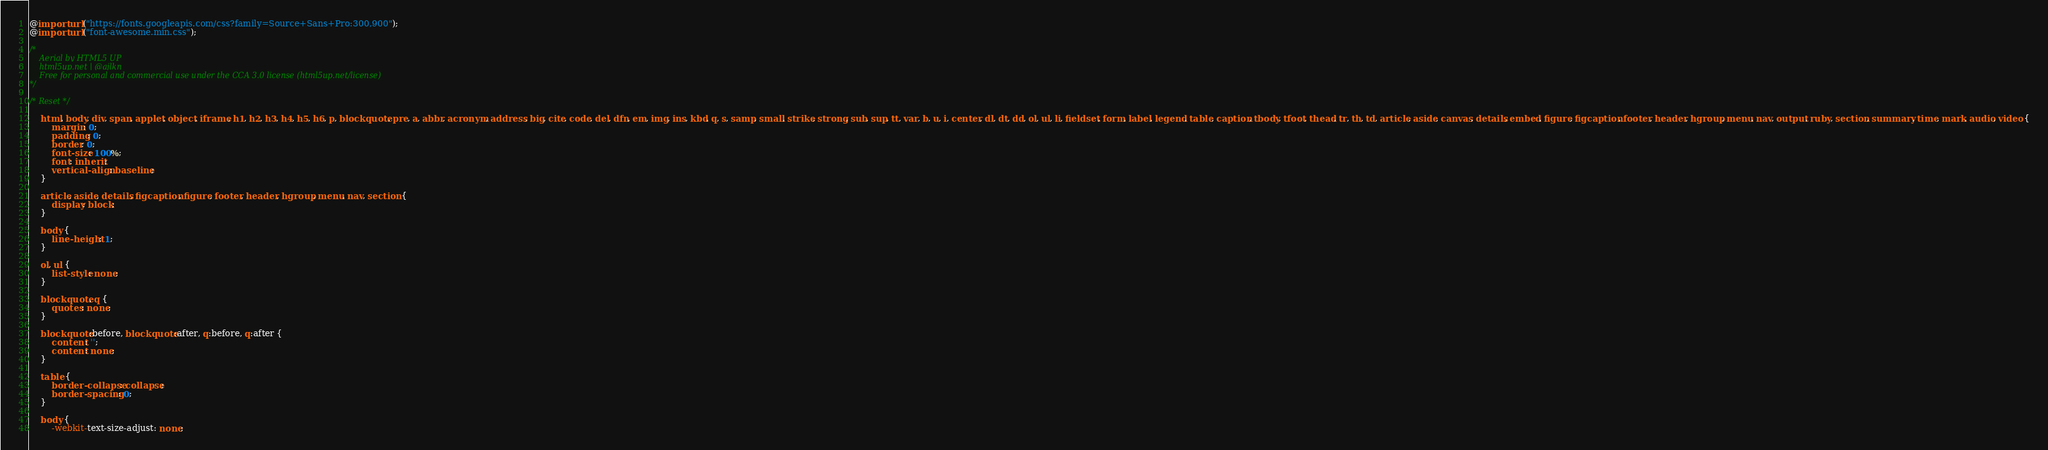<code> <loc_0><loc_0><loc_500><loc_500><_CSS_>@import url("https://fonts.googleapis.com/css?family=Source+Sans+Pro:300,900");
@import url("font-awesome.min.css");

/*
	Aerial by HTML5 UP
	html5up.net | @ajlkn
	Free for personal and commercial use under the CCA 3.0 license (html5up.net/license)
*/

/* Reset */

	html, body, div, span, applet, object, iframe, h1, h2, h3, h4, h5, h6, p, blockquote, pre, a, abbr, acronym, address, big, cite, code, del, dfn, em, img, ins, kbd, q, s, samp, small, strike, strong, sub, sup, tt, var, b, u, i, center, dl, dt, dd, ol, ul, li, fieldset, form, label, legend, table, caption, tbody, tfoot, thead, tr, th, td, article, aside, canvas, details, embed, figure, figcaption, footer, header, hgroup, menu, nav, output, ruby, section, summary, time, mark, audio, video {
		margin: 0;
		padding: 0;
		border: 0;
		font-size: 100%;
		font: inherit;
		vertical-align: baseline;
	}

	article, aside, details, figcaption, figure, footer, header, hgroup, menu, nav, section {
		display: block;
	}

	body {
		line-height: 1;
	}

	ol, ul {
		list-style: none;
	}

	blockquote, q {
		quotes: none;
	}

	blockquote:before, blockquote:after, q:before, q:after {
		content: '';
		content: none;
	}

	table {
		border-collapse: collapse;
		border-spacing: 0;
	}

	body {
		-webkit-text-size-adjust: none;</code> 